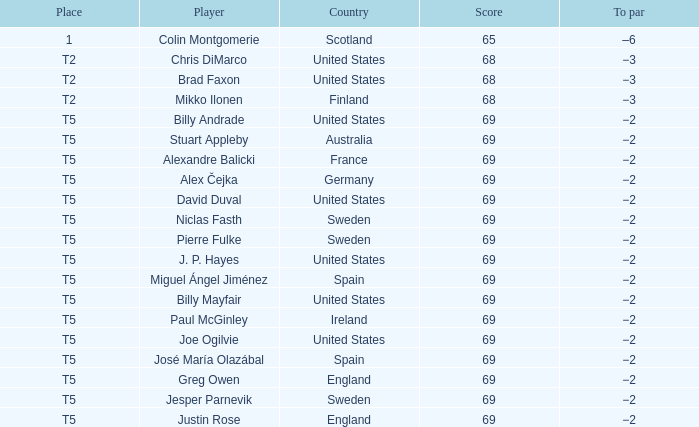What place did Paul McGinley finish in? T5. 